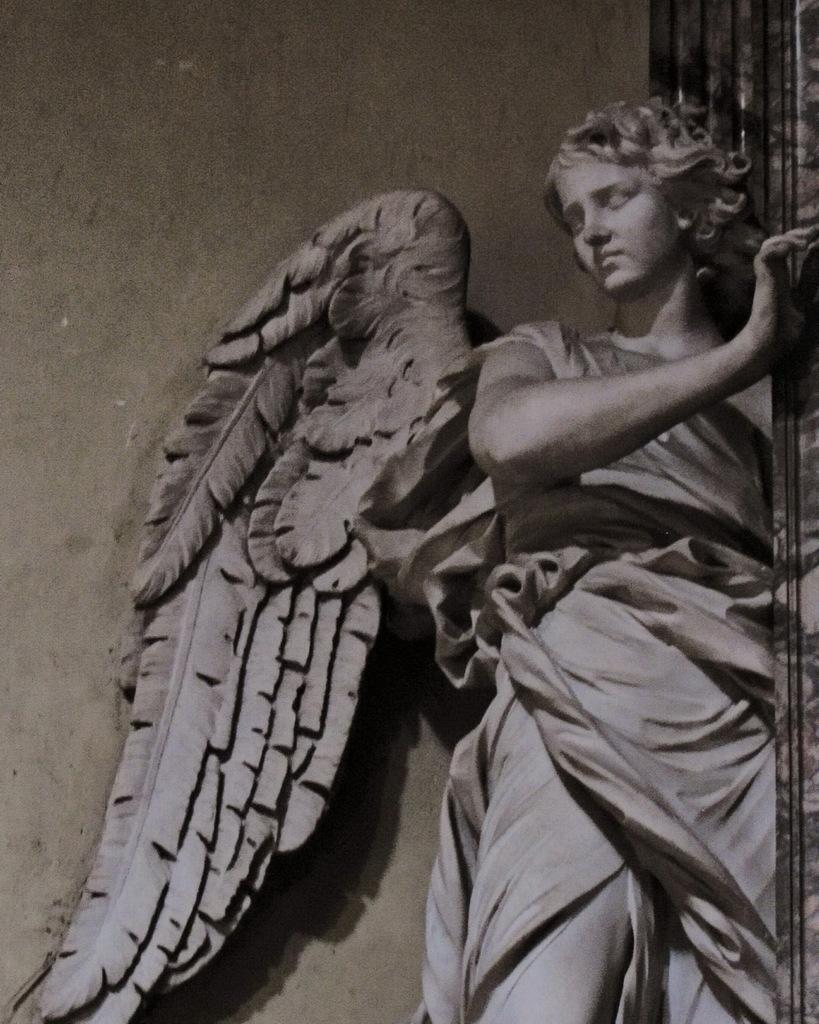How would you summarize this image in a sentence or two? In this image we can see a statue, wall and an object on the right side. 